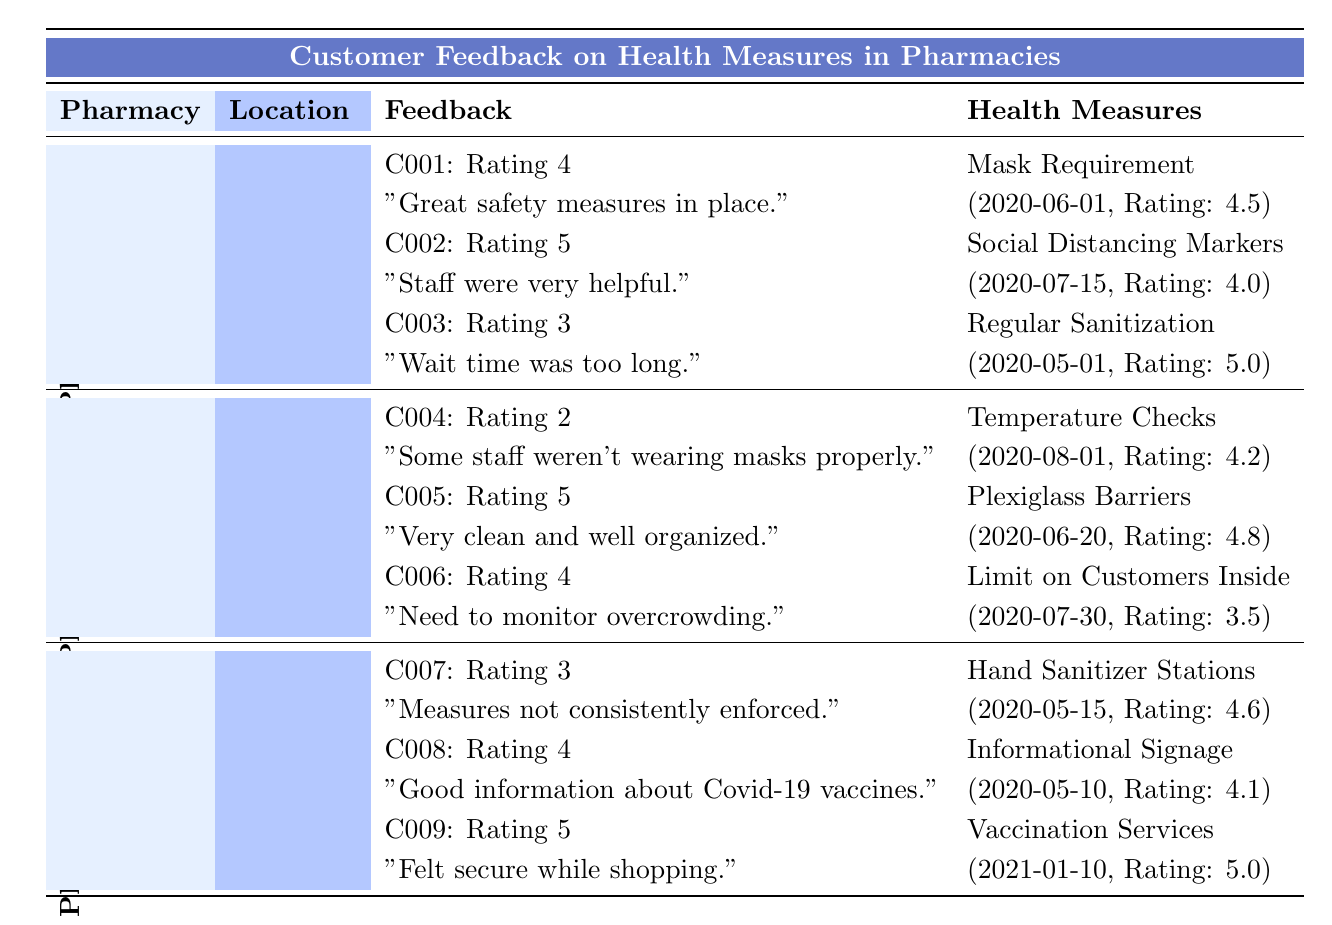What is the effectiveness rating of the "Regular Sanitization" measure at Pharmacy A? From the table, under Pharmacy A's Health Measures, I can see that "Regular Sanitization" has an effectiveness rating of 5.0.
Answer: 5.0 Which pharmacy has the least customer ratings based on feedback? By reviewing the Feedback section for each pharmacy, I find that Pharmacy B has a lowest rating of 2 (C004) among its customer feedback, which is lower than Pharmacy A and C.
Answer: Pharmacy B What is the average effectiveness rating of the health measures at Pharmacy C? For Pharmacy C, the effectiveness ratings of its health measures are 4.6 (Hand Sanitizer Stations), 4.1 (Informational Signage), and 5.0 (Vaccination Services). To find the average, I sum these ratings: 4.6 + 4.1 + 5.0 = 13.7. Then, divide by the number of measures, which is 3: 13.7 / 3 = 4.5667. Rounding gives approximately 4.57.
Answer: 4.57 Did Pharmacy A receive any negative feedback regarding wait times? Yes, in the Feedback section for Pharmacy A, Customer C003 commented on the long wait time, indicating it negatively impacted their experience despite the positive measures in place.
Answer: Yes Which health measure at Pharmacy B has the highest effectiveness rating? Looking at the Health Measures for Pharmacy B, I see that "Plexiglass Barriers" has an effectiveness rating of 4.8, which is higher than both Temperature Checks (4.2) and Limit on Customers Inside (3.5).
Answer: Plexiglass Barriers 